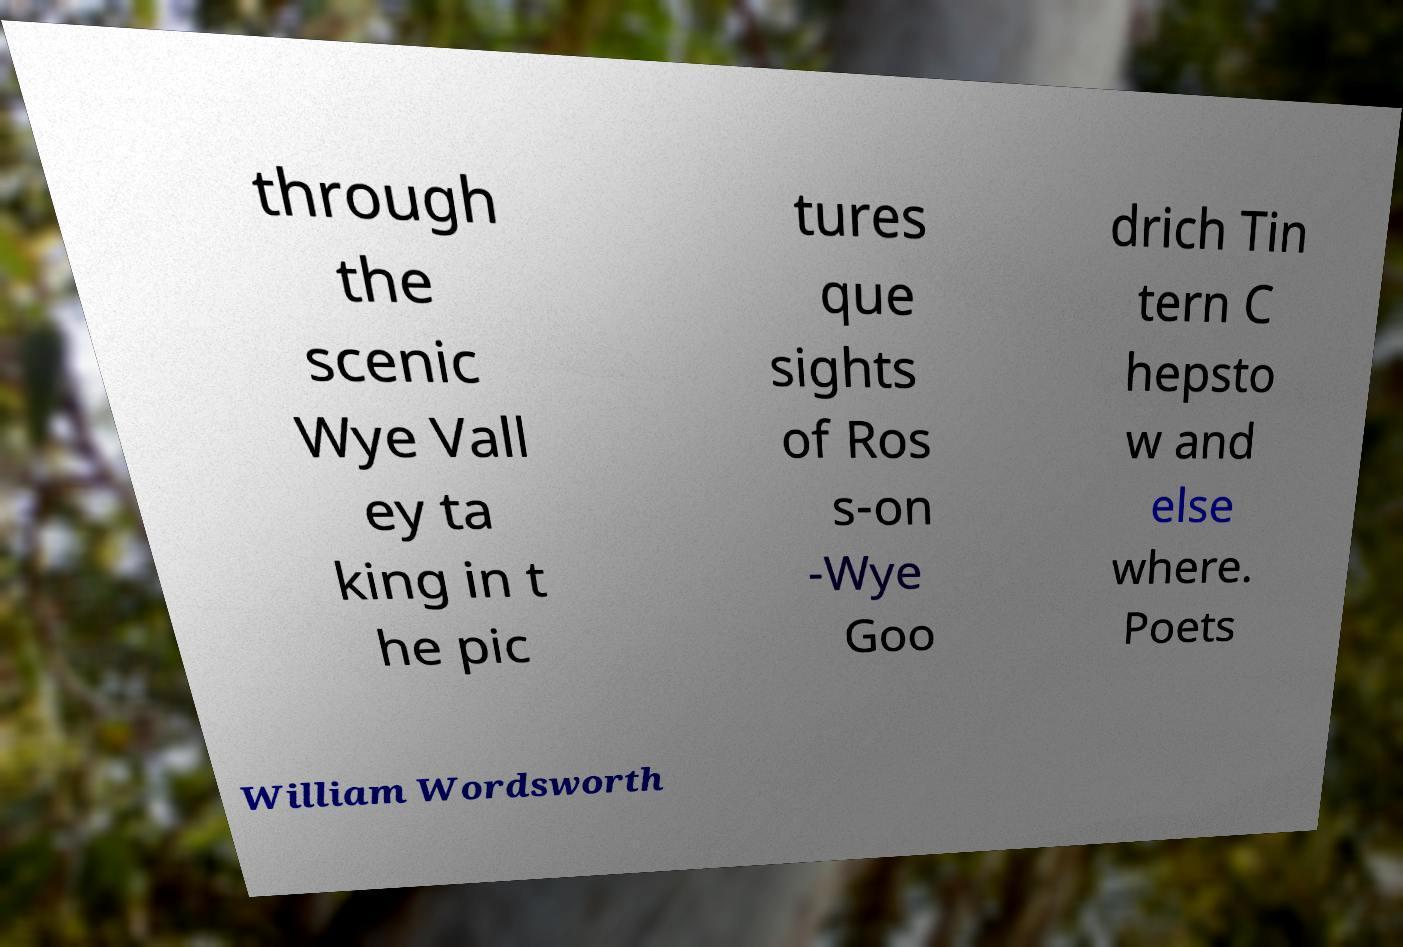Could you extract and type out the text from this image? through the scenic Wye Vall ey ta king in t he pic tures que sights of Ros s-on -Wye Goo drich Tin tern C hepsto w and else where. Poets William Wordsworth 